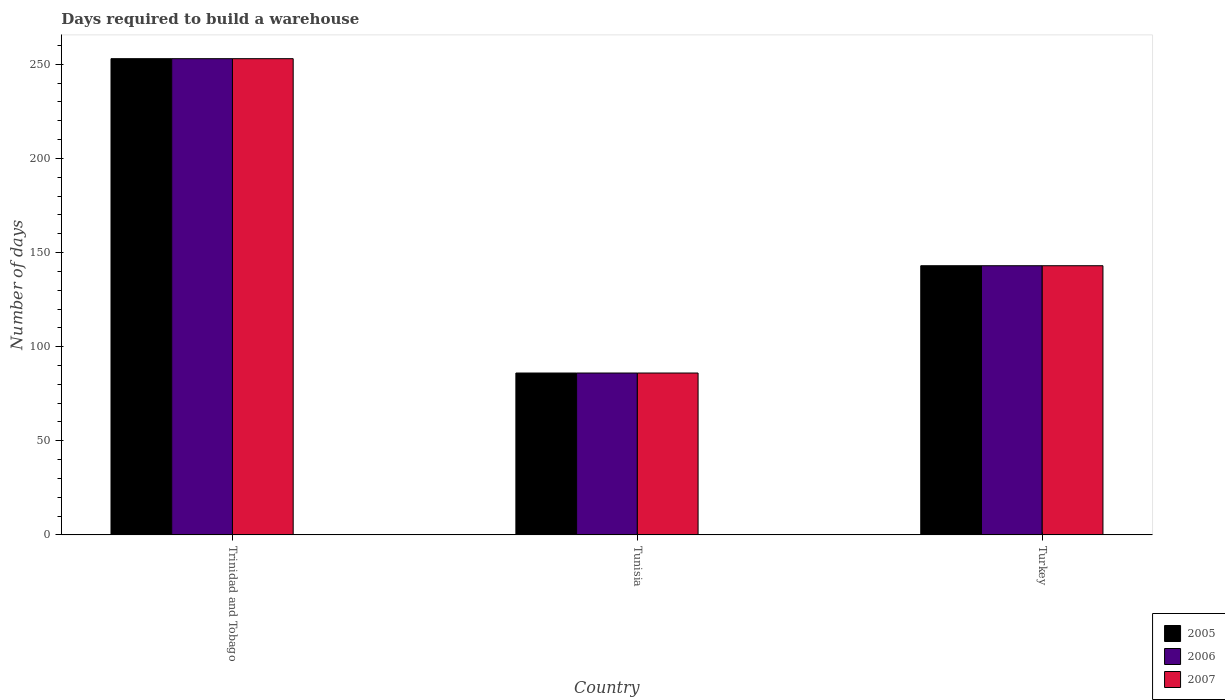How many different coloured bars are there?
Your answer should be very brief. 3. Are the number of bars per tick equal to the number of legend labels?
Offer a very short reply. Yes. Are the number of bars on each tick of the X-axis equal?
Offer a very short reply. Yes. What is the label of the 1st group of bars from the left?
Keep it short and to the point. Trinidad and Tobago. In how many cases, is the number of bars for a given country not equal to the number of legend labels?
Offer a very short reply. 0. What is the days required to build a warehouse in in 2005 in Turkey?
Give a very brief answer. 143. Across all countries, what is the maximum days required to build a warehouse in in 2007?
Make the answer very short. 253. Across all countries, what is the minimum days required to build a warehouse in in 2007?
Your answer should be very brief. 86. In which country was the days required to build a warehouse in in 2005 maximum?
Keep it short and to the point. Trinidad and Tobago. In which country was the days required to build a warehouse in in 2005 minimum?
Provide a succinct answer. Tunisia. What is the total days required to build a warehouse in in 2006 in the graph?
Make the answer very short. 482. What is the difference between the days required to build a warehouse in in 2006 in Trinidad and Tobago and that in Turkey?
Provide a succinct answer. 110. What is the difference between the days required to build a warehouse in in 2007 in Tunisia and the days required to build a warehouse in in 2006 in Turkey?
Ensure brevity in your answer.  -57. What is the average days required to build a warehouse in in 2006 per country?
Your answer should be very brief. 160.67. What is the ratio of the days required to build a warehouse in in 2007 in Trinidad and Tobago to that in Tunisia?
Your response must be concise. 2.94. What is the difference between the highest and the second highest days required to build a warehouse in in 2005?
Provide a short and direct response. 167. What is the difference between the highest and the lowest days required to build a warehouse in in 2005?
Your answer should be very brief. 167. In how many countries, is the days required to build a warehouse in in 2006 greater than the average days required to build a warehouse in in 2006 taken over all countries?
Keep it short and to the point. 1. What does the 2nd bar from the right in Tunisia represents?
Provide a succinct answer. 2006. How many bars are there?
Offer a very short reply. 9. How many countries are there in the graph?
Your answer should be very brief. 3. Are the values on the major ticks of Y-axis written in scientific E-notation?
Keep it short and to the point. No. Does the graph contain any zero values?
Offer a very short reply. No. Where does the legend appear in the graph?
Your answer should be compact. Bottom right. How many legend labels are there?
Your answer should be compact. 3. What is the title of the graph?
Give a very brief answer. Days required to build a warehouse. What is the label or title of the Y-axis?
Keep it short and to the point. Number of days. What is the Number of days of 2005 in Trinidad and Tobago?
Your response must be concise. 253. What is the Number of days of 2006 in Trinidad and Tobago?
Keep it short and to the point. 253. What is the Number of days of 2007 in Trinidad and Tobago?
Provide a short and direct response. 253. What is the Number of days in 2006 in Tunisia?
Your response must be concise. 86. What is the Number of days of 2007 in Tunisia?
Keep it short and to the point. 86. What is the Number of days in 2005 in Turkey?
Your answer should be compact. 143. What is the Number of days in 2006 in Turkey?
Your response must be concise. 143. What is the Number of days in 2007 in Turkey?
Your answer should be compact. 143. Across all countries, what is the maximum Number of days in 2005?
Keep it short and to the point. 253. Across all countries, what is the maximum Number of days of 2006?
Your answer should be compact. 253. Across all countries, what is the maximum Number of days in 2007?
Your answer should be compact. 253. Across all countries, what is the minimum Number of days in 2005?
Give a very brief answer. 86. Across all countries, what is the minimum Number of days in 2007?
Your response must be concise. 86. What is the total Number of days in 2005 in the graph?
Provide a short and direct response. 482. What is the total Number of days in 2006 in the graph?
Give a very brief answer. 482. What is the total Number of days of 2007 in the graph?
Ensure brevity in your answer.  482. What is the difference between the Number of days of 2005 in Trinidad and Tobago and that in Tunisia?
Your answer should be compact. 167. What is the difference between the Number of days in 2006 in Trinidad and Tobago and that in Tunisia?
Make the answer very short. 167. What is the difference between the Number of days in 2007 in Trinidad and Tobago and that in Tunisia?
Provide a short and direct response. 167. What is the difference between the Number of days of 2005 in Trinidad and Tobago and that in Turkey?
Give a very brief answer. 110. What is the difference between the Number of days of 2006 in Trinidad and Tobago and that in Turkey?
Keep it short and to the point. 110. What is the difference between the Number of days of 2007 in Trinidad and Tobago and that in Turkey?
Provide a succinct answer. 110. What is the difference between the Number of days in 2005 in Tunisia and that in Turkey?
Make the answer very short. -57. What is the difference between the Number of days in 2006 in Tunisia and that in Turkey?
Provide a succinct answer. -57. What is the difference between the Number of days in 2007 in Tunisia and that in Turkey?
Keep it short and to the point. -57. What is the difference between the Number of days in 2005 in Trinidad and Tobago and the Number of days in 2006 in Tunisia?
Your response must be concise. 167. What is the difference between the Number of days in 2005 in Trinidad and Tobago and the Number of days in 2007 in Tunisia?
Ensure brevity in your answer.  167. What is the difference between the Number of days of 2006 in Trinidad and Tobago and the Number of days of 2007 in Tunisia?
Ensure brevity in your answer.  167. What is the difference between the Number of days of 2005 in Trinidad and Tobago and the Number of days of 2006 in Turkey?
Make the answer very short. 110. What is the difference between the Number of days in 2005 in Trinidad and Tobago and the Number of days in 2007 in Turkey?
Keep it short and to the point. 110. What is the difference between the Number of days of 2006 in Trinidad and Tobago and the Number of days of 2007 in Turkey?
Make the answer very short. 110. What is the difference between the Number of days in 2005 in Tunisia and the Number of days in 2006 in Turkey?
Your answer should be compact. -57. What is the difference between the Number of days of 2005 in Tunisia and the Number of days of 2007 in Turkey?
Your response must be concise. -57. What is the difference between the Number of days in 2006 in Tunisia and the Number of days in 2007 in Turkey?
Provide a short and direct response. -57. What is the average Number of days of 2005 per country?
Offer a terse response. 160.67. What is the average Number of days in 2006 per country?
Keep it short and to the point. 160.67. What is the average Number of days in 2007 per country?
Your answer should be very brief. 160.67. What is the difference between the Number of days in 2006 and Number of days in 2007 in Trinidad and Tobago?
Offer a terse response. 0. What is the difference between the Number of days in 2005 and Number of days in 2006 in Turkey?
Keep it short and to the point. 0. What is the difference between the Number of days of 2005 and Number of days of 2007 in Turkey?
Provide a succinct answer. 0. What is the ratio of the Number of days of 2005 in Trinidad and Tobago to that in Tunisia?
Your answer should be very brief. 2.94. What is the ratio of the Number of days in 2006 in Trinidad and Tobago to that in Tunisia?
Keep it short and to the point. 2.94. What is the ratio of the Number of days in 2007 in Trinidad and Tobago to that in Tunisia?
Give a very brief answer. 2.94. What is the ratio of the Number of days in 2005 in Trinidad and Tobago to that in Turkey?
Your answer should be very brief. 1.77. What is the ratio of the Number of days in 2006 in Trinidad and Tobago to that in Turkey?
Make the answer very short. 1.77. What is the ratio of the Number of days of 2007 in Trinidad and Tobago to that in Turkey?
Provide a short and direct response. 1.77. What is the ratio of the Number of days in 2005 in Tunisia to that in Turkey?
Your response must be concise. 0.6. What is the ratio of the Number of days in 2006 in Tunisia to that in Turkey?
Provide a succinct answer. 0.6. What is the ratio of the Number of days in 2007 in Tunisia to that in Turkey?
Ensure brevity in your answer.  0.6. What is the difference between the highest and the second highest Number of days in 2005?
Your answer should be very brief. 110. What is the difference between the highest and the second highest Number of days in 2006?
Your answer should be compact. 110. What is the difference between the highest and the second highest Number of days of 2007?
Your response must be concise. 110. What is the difference between the highest and the lowest Number of days in 2005?
Ensure brevity in your answer.  167. What is the difference between the highest and the lowest Number of days in 2006?
Keep it short and to the point. 167. What is the difference between the highest and the lowest Number of days of 2007?
Offer a terse response. 167. 